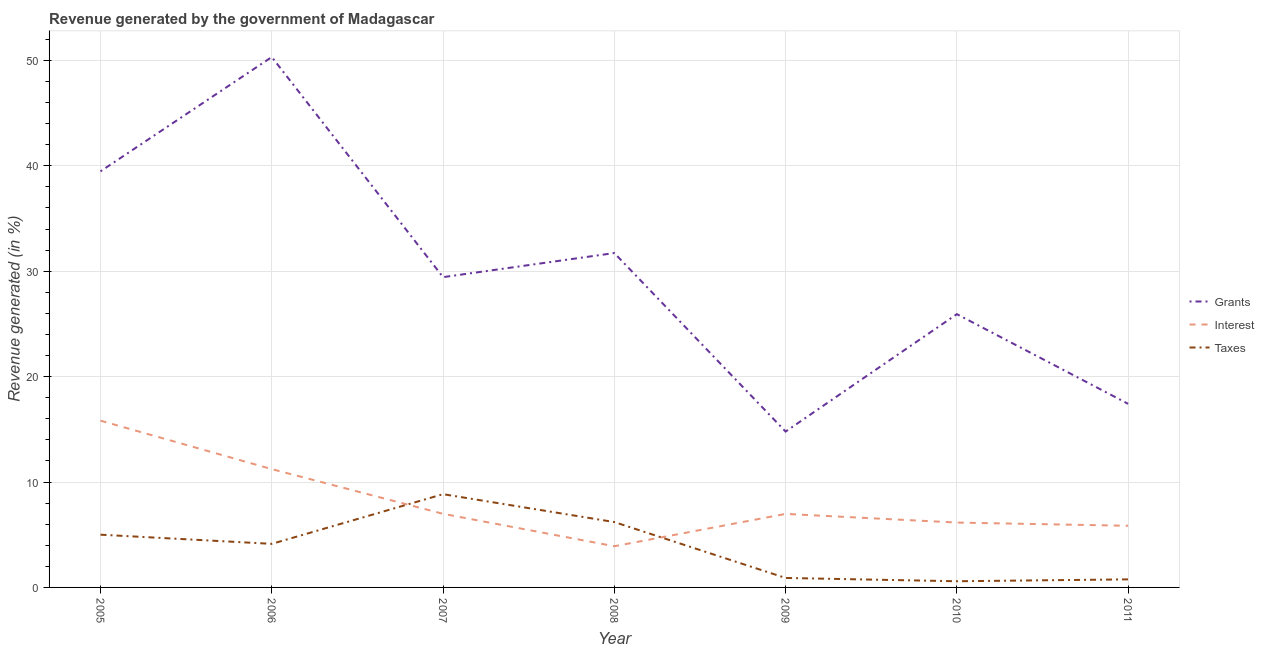How many different coloured lines are there?
Give a very brief answer. 3. What is the percentage of revenue generated by taxes in 2008?
Provide a succinct answer. 6.2. Across all years, what is the maximum percentage of revenue generated by taxes?
Make the answer very short. 8.85. Across all years, what is the minimum percentage of revenue generated by grants?
Your answer should be very brief. 14.79. What is the total percentage of revenue generated by interest in the graph?
Offer a very short reply. 56.91. What is the difference between the percentage of revenue generated by interest in 2005 and that in 2006?
Offer a very short reply. 4.6. What is the difference between the percentage of revenue generated by interest in 2008 and the percentage of revenue generated by grants in 2009?
Your answer should be very brief. -10.88. What is the average percentage of revenue generated by grants per year?
Provide a succinct answer. 29.87. In the year 2011, what is the difference between the percentage of revenue generated by grants and percentage of revenue generated by taxes?
Offer a very short reply. 16.65. In how many years, is the percentage of revenue generated by taxes greater than 34 %?
Your answer should be compact. 0. What is the ratio of the percentage of revenue generated by taxes in 2007 to that in 2011?
Give a very brief answer. 11.58. What is the difference between the highest and the second highest percentage of revenue generated by taxes?
Offer a terse response. 2.65. What is the difference between the highest and the lowest percentage of revenue generated by grants?
Your answer should be compact. 35.53. In how many years, is the percentage of revenue generated by taxes greater than the average percentage of revenue generated by taxes taken over all years?
Your answer should be very brief. 4. Is it the case that in every year, the sum of the percentage of revenue generated by grants and percentage of revenue generated by interest is greater than the percentage of revenue generated by taxes?
Provide a short and direct response. Yes. Does the percentage of revenue generated by taxes monotonically increase over the years?
Your answer should be very brief. No. Is the percentage of revenue generated by taxes strictly greater than the percentage of revenue generated by interest over the years?
Make the answer very short. No. What is the difference between two consecutive major ticks on the Y-axis?
Give a very brief answer. 10. Are the values on the major ticks of Y-axis written in scientific E-notation?
Provide a short and direct response. No. Does the graph contain grids?
Keep it short and to the point. Yes. How many legend labels are there?
Give a very brief answer. 3. How are the legend labels stacked?
Provide a short and direct response. Vertical. What is the title of the graph?
Keep it short and to the point. Revenue generated by the government of Madagascar. What is the label or title of the Y-axis?
Offer a very short reply. Revenue generated (in %). What is the Revenue generated (in %) in Grants in 2005?
Provide a succinct answer. 39.48. What is the Revenue generated (in %) in Interest in 2005?
Ensure brevity in your answer.  15.82. What is the Revenue generated (in %) of Taxes in 2005?
Make the answer very short. 5. What is the Revenue generated (in %) of Grants in 2006?
Give a very brief answer. 50.32. What is the Revenue generated (in %) of Interest in 2006?
Provide a short and direct response. 11.22. What is the Revenue generated (in %) in Taxes in 2006?
Your answer should be very brief. 4.13. What is the Revenue generated (in %) of Grants in 2007?
Offer a very short reply. 29.44. What is the Revenue generated (in %) in Interest in 2007?
Your answer should be very brief. 6.98. What is the Revenue generated (in %) of Taxes in 2007?
Your answer should be compact. 8.85. What is the Revenue generated (in %) of Grants in 2008?
Offer a very short reply. 31.72. What is the Revenue generated (in %) in Interest in 2008?
Offer a very short reply. 3.91. What is the Revenue generated (in %) of Taxes in 2008?
Your response must be concise. 6.2. What is the Revenue generated (in %) of Grants in 2009?
Offer a terse response. 14.79. What is the Revenue generated (in %) in Interest in 2009?
Provide a short and direct response. 6.98. What is the Revenue generated (in %) in Taxes in 2009?
Offer a very short reply. 0.9. What is the Revenue generated (in %) in Grants in 2010?
Your response must be concise. 25.93. What is the Revenue generated (in %) in Interest in 2010?
Your answer should be very brief. 6.15. What is the Revenue generated (in %) of Taxes in 2010?
Provide a short and direct response. 0.59. What is the Revenue generated (in %) of Grants in 2011?
Offer a very short reply. 17.42. What is the Revenue generated (in %) in Interest in 2011?
Your answer should be very brief. 5.85. What is the Revenue generated (in %) of Taxes in 2011?
Give a very brief answer. 0.76. Across all years, what is the maximum Revenue generated (in %) in Grants?
Offer a terse response. 50.32. Across all years, what is the maximum Revenue generated (in %) in Interest?
Keep it short and to the point. 15.82. Across all years, what is the maximum Revenue generated (in %) in Taxes?
Offer a very short reply. 8.85. Across all years, what is the minimum Revenue generated (in %) of Grants?
Keep it short and to the point. 14.79. Across all years, what is the minimum Revenue generated (in %) of Interest?
Provide a succinct answer. 3.91. Across all years, what is the minimum Revenue generated (in %) in Taxes?
Provide a succinct answer. 0.59. What is the total Revenue generated (in %) in Grants in the graph?
Offer a very short reply. 209.08. What is the total Revenue generated (in %) in Interest in the graph?
Provide a succinct answer. 56.91. What is the total Revenue generated (in %) in Taxes in the graph?
Your response must be concise. 26.43. What is the difference between the Revenue generated (in %) in Grants in 2005 and that in 2006?
Offer a terse response. -10.84. What is the difference between the Revenue generated (in %) in Interest in 2005 and that in 2006?
Provide a short and direct response. 4.6. What is the difference between the Revenue generated (in %) of Taxes in 2005 and that in 2006?
Your answer should be very brief. 0.87. What is the difference between the Revenue generated (in %) of Grants in 2005 and that in 2007?
Ensure brevity in your answer.  10.04. What is the difference between the Revenue generated (in %) in Interest in 2005 and that in 2007?
Your answer should be very brief. 8.84. What is the difference between the Revenue generated (in %) of Taxes in 2005 and that in 2007?
Your answer should be very brief. -3.84. What is the difference between the Revenue generated (in %) in Grants in 2005 and that in 2008?
Give a very brief answer. 7.75. What is the difference between the Revenue generated (in %) in Interest in 2005 and that in 2008?
Offer a terse response. 11.91. What is the difference between the Revenue generated (in %) in Taxes in 2005 and that in 2008?
Give a very brief answer. -1.2. What is the difference between the Revenue generated (in %) in Grants in 2005 and that in 2009?
Your response must be concise. 24.69. What is the difference between the Revenue generated (in %) in Interest in 2005 and that in 2009?
Give a very brief answer. 8.85. What is the difference between the Revenue generated (in %) in Taxes in 2005 and that in 2009?
Your answer should be compact. 4.1. What is the difference between the Revenue generated (in %) in Grants in 2005 and that in 2010?
Offer a very short reply. 13.55. What is the difference between the Revenue generated (in %) in Interest in 2005 and that in 2010?
Your answer should be compact. 9.67. What is the difference between the Revenue generated (in %) of Taxes in 2005 and that in 2010?
Offer a very short reply. 4.42. What is the difference between the Revenue generated (in %) of Grants in 2005 and that in 2011?
Your response must be concise. 22.06. What is the difference between the Revenue generated (in %) in Interest in 2005 and that in 2011?
Provide a short and direct response. 9.97. What is the difference between the Revenue generated (in %) in Taxes in 2005 and that in 2011?
Your response must be concise. 4.24. What is the difference between the Revenue generated (in %) in Grants in 2006 and that in 2007?
Provide a short and direct response. 20.88. What is the difference between the Revenue generated (in %) of Interest in 2006 and that in 2007?
Offer a very short reply. 4.24. What is the difference between the Revenue generated (in %) in Taxes in 2006 and that in 2007?
Provide a short and direct response. -4.71. What is the difference between the Revenue generated (in %) of Grants in 2006 and that in 2008?
Your answer should be very brief. 18.6. What is the difference between the Revenue generated (in %) of Interest in 2006 and that in 2008?
Your answer should be compact. 7.32. What is the difference between the Revenue generated (in %) in Taxes in 2006 and that in 2008?
Offer a very short reply. -2.07. What is the difference between the Revenue generated (in %) in Grants in 2006 and that in 2009?
Provide a short and direct response. 35.53. What is the difference between the Revenue generated (in %) in Interest in 2006 and that in 2009?
Offer a terse response. 4.25. What is the difference between the Revenue generated (in %) of Taxes in 2006 and that in 2009?
Give a very brief answer. 3.23. What is the difference between the Revenue generated (in %) of Grants in 2006 and that in 2010?
Provide a short and direct response. 24.39. What is the difference between the Revenue generated (in %) of Interest in 2006 and that in 2010?
Your answer should be compact. 5.07. What is the difference between the Revenue generated (in %) in Taxes in 2006 and that in 2010?
Provide a succinct answer. 3.55. What is the difference between the Revenue generated (in %) in Grants in 2006 and that in 2011?
Your answer should be compact. 32.9. What is the difference between the Revenue generated (in %) of Interest in 2006 and that in 2011?
Give a very brief answer. 5.37. What is the difference between the Revenue generated (in %) in Taxes in 2006 and that in 2011?
Ensure brevity in your answer.  3.37. What is the difference between the Revenue generated (in %) of Grants in 2007 and that in 2008?
Your response must be concise. -2.29. What is the difference between the Revenue generated (in %) in Interest in 2007 and that in 2008?
Your response must be concise. 3.07. What is the difference between the Revenue generated (in %) in Taxes in 2007 and that in 2008?
Your answer should be compact. 2.65. What is the difference between the Revenue generated (in %) of Grants in 2007 and that in 2009?
Provide a succinct answer. 14.65. What is the difference between the Revenue generated (in %) of Interest in 2007 and that in 2009?
Your answer should be compact. 0.01. What is the difference between the Revenue generated (in %) in Taxes in 2007 and that in 2009?
Offer a very short reply. 7.95. What is the difference between the Revenue generated (in %) in Grants in 2007 and that in 2010?
Your answer should be very brief. 3.51. What is the difference between the Revenue generated (in %) of Interest in 2007 and that in 2010?
Ensure brevity in your answer.  0.83. What is the difference between the Revenue generated (in %) of Taxes in 2007 and that in 2010?
Your response must be concise. 8.26. What is the difference between the Revenue generated (in %) in Grants in 2007 and that in 2011?
Your answer should be compact. 12.02. What is the difference between the Revenue generated (in %) in Interest in 2007 and that in 2011?
Offer a very short reply. 1.13. What is the difference between the Revenue generated (in %) of Taxes in 2007 and that in 2011?
Offer a terse response. 8.08. What is the difference between the Revenue generated (in %) of Grants in 2008 and that in 2009?
Offer a terse response. 16.93. What is the difference between the Revenue generated (in %) of Interest in 2008 and that in 2009?
Your response must be concise. -3.07. What is the difference between the Revenue generated (in %) of Taxes in 2008 and that in 2009?
Provide a short and direct response. 5.3. What is the difference between the Revenue generated (in %) in Grants in 2008 and that in 2010?
Give a very brief answer. 5.8. What is the difference between the Revenue generated (in %) of Interest in 2008 and that in 2010?
Provide a succinct answer. -2.25. What is the difference between the Revenue generated (in %) of Taxes in 2008 and that in 2010?
Your answer should be compact. 5.61. What is the difference between the Revenue generated (in %) in Grants in 2008 and that in 2011?
Offer a terse response. 14.3. What is the difference between the Revenue generated (in %) of Interest in 2008 and that in 2011?
Make the answer very short. -1.94. What is the difference between the Revenue generated (in %) in Taxes in 2008 and that in 2011?
Make the answer very short. 5.44. What is the difference between the Revenue generated (in %) of Grants in 2009 and that in 2010?
Your response must be concise. -11.14. What is the difference between the Revenue generated (in %) in Interest in 2009 and that in 2010?
Provide a short and direct response. 0.82. What is the difference between the Revenue generated (in %) of Taxes in 2009 and that in 2010?
Your answer should be compact. 0.31. What is the difference between the Revenue generated (in %) in Grants in 2009 and that in 2011?
Your answer should be very brief. -2.63. What is the difference between the Revenue generated (in %) in Interest in 2009 and that in 2011?
Provide a succinct answer. 1.13. What is the difference between the Revenue generated (in %) in Taxes in 2009 and that in 2011?
Offer a terse response. 0.14. What is the difference between the Revenue generated (in %) of Grants in 2010 and that in 2011?
Keep it short and to the point. 8.51. What is the difference between the Revenue generated (in %) in Interest in 2010 and that in 2011?
Your response must be concise. 0.3. What is the difference between the Revenue generated (in %) of Taxes in 2010 and that in 2011?
Your response must be concise. -0.18. What is the difference between the Revenue generated (in %) in Grants in 2005 and the Revenue generated (in %) in Interest in 2006?
Give a very brief answer. 28.25. What is the difference between the Revenue generated (in %) in Grants in 2005 and the Revenue generated (in %) in Taxes in 2006?
Ensure brevity in your answer.  35.34. What is the difference between the Revenue generated (in %) in Interest in 2005 and the Revenue generated (in %) in Taxes in 2006?
Provide a succinct answer. 11.69. What is the difference between the Revenue generated (in %) of Grants in 2005 and the Revenue generated (in %) of Interest in 2007?
Keep it short and to the point. 32.49. What is the difference between the Revenue generated (in %) in Grants in 2005 and the Revenue generated (in %) in Taxes in 2007?
Give a very brief answer. 30.63. What is the difference between the Revenue generated (in %) in Interest in 2005 and the Revenue generated (in %) in Taxes in 2007?
Your response must be concise. 6.97. What is the difference between the Revenue generated (in %) of Grants in 2005 and the Revenue generated (in %) of Interest in 2008?
Give a very brief answer. 35.57. What is the difference between the Revenue generated (in %) in Grants in 2005 and the Revenue generated (in %) in Taxes in 2008?
Make the answer very short. 33.27. What is the difference between the Revenue generated (in %) of Interest in 2005 and the Revenue generated (in %) of Taxes in 2008?
Ensure brevity in your answer.  9.62. What is the difference between the Revenue generated (in %) of Grants in 2005 and the Revenue generated (in %) of Interest in 2009?
Provide a succinct answer. 32.5. What is the difference between the Revenue generated (in %) in Grants in 2005 and the Revenue generated (in %) in Taxes in 2009?
Ensure brevity in your answer.  38.58. What is the difference between the Revenue generated (in %) in Interest in 2005 and the Revenue generated (in %) in Taxes in 2009?
Your response must be concise. 14.92. What is the difference between the Revenue generated (in %) in Grants in 2005 and the Revenue generated (in %) in Interest in 2010?
Keep it short and to the point. 33.32. What is the difference between the Revenue generated (in %) of Grants in 2005 and the Revenue generated (in %) of Taxes in 2010?
Your answer should be very brief. 38.89. What is the difference between the Revenue generated (in %) of Interest in 2005 and the Revenue generated (in %) of Taxes in 2010?
Your answer should be compact. 15.23. What is the difference between the Revenue generated (in %) of Grants in 2005 and the Revenue generated (in %) of Interest in 2011?
Keep it short and to the point. 33.63. What is the difference between the Revenue generated (in %) of Grants in 2005 and the Revenue generated (in %) of Taxes in 2011?
Your answer should be compact. 38.71. What is the difference between the Revenue generated (in %) in Interest in 2005 and the Revenue generated (in %) in Taxes in 2011?
Your answer should be compact. 15.06. What is the difference between the Revenue generated (in %) of Grants in 2006 and the Revenue generated (in %) of Interest in 2007?
Give a very brief answer. 43.33. What is the difference between the Revenue generated (in %) in Grants in 2006 and the Revenue generated (in %) in Taxes in 2007?
Your response must be concise. 41.47. What is the difference between the Revenue generated (in %) in Interest in 2006 and the Revenue generated (in %) in Taxes in 2007?
Provide a succinct answer. 2.38. What is the difference between the Revenue generated (in %) in Grants in 2006 and the Revenue generated (in %) in Interest in 2008?
Give a very brief answer. 46.41. What is the difference between the Revenue generated (in %) of Grants in 2006 and the Revenue generated (in %) of Taxes in 2008?
Ensure brevity in your answer.  44.12. What is the difference between the Revenue generated (in %) in Interest in 2006 and the Revenue generated (in %) in Taxes in 2008?
Provide a short and direct response. 5.02. What is the difference between the Revenue generated (in %) of Grants in 2006 and the Revenue generated (in %) of Interest in 2009?
Provide a succinct answer. 43.34. What is the difference between the Revenue generated (in %) of Grants in 2006 and the Revenue generated (in %) of Taxes in 2009?
Offer a very short reply. 49.42. What is the difference between the Revenue generated (in %) in Interest in 2006 and the Revenue generated (in %) in Taxes in 2009?
Your answer should be very brief. 10.32. What is the difference between the Revenue generated (in %) of Grants in 2006 and the Revenue generated (in %) of Interest in 2010?
Your answer should be compact. 44.16. What is the difference between the Revenue generated (in %) of Grants in 2006 and the Revenue generated (in %) of Taxes in 2010?
Your answer should be very brief. 49.73. What is the difference between the Revenue generated (in %) in Interest in 2006 and the Revenue generated (in %) in Taxes in 2010?
Provide a succinct answer. 10.64. What is the difference between the Revenue generated (in %) in Grants in 2006 and the Revenue generated (in %) in Interest in 2011?
Provide a short and direct response. 44.47. What is the difference between the Revenue generated (in %) in Grants in 2006 and the Revenue generated (in %) in Taxes in 2011?
Keep it short and to the point. 49.55. What is the difference between the Revenue generated (in %) of Interest in 2006 and the Revenue generated (in %) of Taxes in 2011?
Your answer should be very brief. 10.46. What is the difference between the Revenue generated (in %) in Grants in 2007 and the Revenue generated (in %) in Interest in 2008?
Ensure brevity in your answer.  25.53. What is the difference between the Revenue generated (in %) in Grants in 2007 and the Revenue generated (in %) in Taxes in 2008?
Keep it short and to the point. 23.24. What is the difference between the Revenue generated (in %) in Interest in 2007 and the Revenue generated (in %) in Taxes in 2008?
Provide a short and direct response. 0.78. What is the difference between the Revenue generated (in %) of Grants in 2007 and the Revenue generated (in %) of Interest in 2009?
Your response must be concise. 22.46. What is the difference between the Revenue generated (in %) of Grants in 2007 and the Revenue generated (in %) of Taxes in 2009?
Your response must be concise. 28.54. What is the difference between the Revenue generated (in %) in Interest in 2007 and the Revenue generated (in %) in Taxes in 2009?
Keep it short and to the point. 6.08. What is the difference between the Revenue generated (in %) of Grants in 2007 and the Revenue generated (in %) of Interest in 2010?
Your response must be concise. 23.28. What is the difference between the Revenue generated (in %) of Grants in 2007 and the Revenue generated (in %) of Taxes in 2010?
Keep it short and to the point. 28.85. What is the difference between the Revenue generated (in %) in Interest in 2007 and the Revenue generated (in %) in Taxes in 2010?
Offer a very short reply. 6.4. What is the difference between the Revenue generated (in %) of Grants in 2007 and the Revenue generated (in %) of Interest in 2011?
Your answer should be compact. 23.59. What is the difference between the Revenue generated (in %) of Grants in 2007 and the Revenue generated (in %) of Taxes in 2011?
Offer a terse response. 28.67. What is the difference between the Revenue generated (in %) in Interest in 2007 and the Revenue generated (in %) in Taxes in 2011?
Offer a terse response. 6.22. What is the difference between the Revenue generated (in %) in Grants in 2008 and the Revenue generated (in %) in Interest in 2009?
Your answer should be very brief. 24.75. What is the difference between the Revenue generated (in %) in Grants in 2008 and the Revenue generated (in %) in Taxes in 2009?
Keep it short and to the point. 30.82. What is the difference between the Revenue generated (in %) in Interest in 2008 and the Revenue generated (in %) in Taxes in 2009?
Your answer should be compact. 3.01. What is the difference between the Revenue generated (in %) in Grants in 2008 and the Revenue generated (in %) in Interest in 2010?
Give a very brief answer. 25.57. What is the difference between the Revenue generated (in %) of Grants in 2008 and the Revenue generated (in %) of Taxes in 2010?
Ensure brevity in your answer.  31.14. What is the difference between the Revenue generated (in %) in Interest in 2008 and the Revenue generated (in %) in Taxes in 2010?
Your answer should be very brief. 3.32. What is the difference between the Revenue generated (in %) of Grants in 2008 and the Revenue generated (in %) of Interest in 2011?
Keep it short and to the point. 25.87. What is the difference between the Revenue generated (in %) in Grants in 2008 and the Revenue generated (in %) in Taxes in 2011?
Ensure brevity in your answer.  30.96. What is the difference between the Revenue generated (in %) of Interest in 2008 and the Revenue generated (in %) of Taxes in 2011?
Keep it short and to the point. 3.14. What is the difference between the Revenue generated (in %) in Grants in 2009 and the Revenue generated (in %) in Interest in 2010?
Keep it short and to the point. 8.63. What is the difference between the Revenue generated (in %) in Grants in 2009 and the Revenue generated (in %) in Taxes in 2010?
Give a very brief answer. 14.2. What is the difference between the Revenue generated (in %) in Interest in 2009 and the Revenue generated (in %) in Taxes in 2010?
Your response must be concise. 6.39. What is the difference between the Revenue generated (in %) in Grants in 2009 and the Revenue generated (in %) in Interest in 2011?
Keep it short and to the point. 8.94. What is the difference between the Revenue generated (in %) of Grants in 2009 and the Revenue generated (in %) of Taxes in 2011?
Your answer should be compact. 14.02. What is the difference between the Revenue generated (in %) of Interest in 2009 and the Revenue generated (in %) of Taxes in 2011?
Provide a succinct answer. 6.21. What is the difference between the Revenue generated (in %) of Grants in 2010 and the Revenue generated (in %) of Interest in 2011?
Provide a succinct answer. 20.08. What is the difference between the Revenue generated (in %) of Grants in 2010 and the Revenue generated (in %) of Taxes in 2011?
Keep it short and to the point. 25.16. What is the difference between the Revenue generated (in %) in Interest in 2010 and the Revenue generated (in %) in Taxes in 2011?
Offer a very short reply. 5.39. What is the average Revenue generated (in %) of Grants per year?
Your response must be concise. 29.87. What is the average Revenue generated (in %) of Interest per year?
Your answer should be compact. 8.13. What is the average Revenue generated (in %) in Taxes per year?
Offer a terse response. 3.78. In the year 2005, what is the difference between the Revenue generated (in %) in Grants and Revenue generated (in %) in Interest?
Your answer should be very brief. 23.65. In the year 2005, what is the difference between the Revenue generated (in %) in Grants and Revenue generated (in %) in Taxes?
Provide a short and direct response. 34.47. In the year 2005, what is the difference between the Revenue generated (in %) in Interest and Revenue generated (in %) in Taxes?
Your answer should be very brief. 10.82. In the year 2006, what is the difference between the Revenue generated (in %) of Grants and Revenue generated (in %) of Interest?
Your answer should be compact. 39.09. In the year 2006, what is the difference between the Revenue generated (in %) of Grants and Revenue generated (in %) of Taxes?
Keep it short and to the point. 46.18. In the year 2006, what is the difference between the Revenue generated (in %) in Interest and Revenue generated (in %) in Taxes?
Provide a succinct answer. 7.09. In the year 2007, what is the difference between the Revenue generated (in %) in Grants and Revenue generated (in %) in Interest?
Your answer should be compact. 22.45. In the year 2007, what is the difference between the Revenue generated (in %) of Grants and Revenue generated (in %) of Taxes?
Your answer should be very brief. 20.59. In the year 2007, what is the difference between the Revenue generated (in %) of Interest and Revenue generated (in %) of Taxes?
Your answer should be very brief. -1.86. In the year 2008, what is the difference between the Revenue generated (in %) of Grants and Revenue generated (in %) of Interest?
Give a very brief answer. 27.81. In the year 2008, what is the difference between the Revenue generated (in %) in Grants and Revenue generated (in %) in Taxes?
Your response must be concise. 25.52. In the year 2008, what is the difference between the Revenue generated (in %) in Interest and Revenue generated (in %) in Taxes?
Your response must be concise. -2.29. In the year 2009, what is the difference between the Revenue generated (in %) of Grants and Revenue generated (in %) of Interest?
Provide a succinct answer. 7.81. In the year 2009, what is the difference between the Revenue generated (in %) in Grants and Revenue generated (in %) in Taxes?
Keep it short and to the point. 13.89. In the year 2009, what is the difference between the Revenue generated (in %) in Interest and Revenue generated (in %) in Taxes?
Your response must be concise. 6.08. In the year 2010, what is the difference between the Revenue generated (in %) in Grants and Revenue generated (in %) in Interest?
Your answer should be compact. 19.77. In the year 2010, what is the difference between the Revenue generated (in %) in Grants and Revenue generated (in %) in Taxes?
Ensure brevity in your answer.  25.34. In the year 2010, what is the difference between the Revenue generated (in %) of Interest and Revenue generated (in %) of Taxes?
Ensure brevity in your answer.  5.57. In the year 2011, what is the difference between the Revenue generated (in %) of Grants and Revenue generated (in %) of Interest?
Provide a succinct answer. 11.57. In the year 2011, what is the difference between the Revenue generated (in %) in Grants and Revenue generated (in %) in Taxes?
Offer a terse response. 16.65. In the year 2011, what is the difference between the Revenue generated (in %) of Interest and Revenue generated (in %) of Taxes?
Your response must be concise. 5.08. What is the ratio of the Revenue generated (in %) in Grants in 2005 to that in 2006?
Keep it short and to the point. 0.78. What is the ratio of the Revenue generated (in %) in Interest in 2005 to that in 2006?
Keep it short and to the point. 1.41. What is the ratio of the Revenue generated (in %) of Taxes in 2005 to that in 2006?
Your response must be concise. 1.21. What is the ratio of the Revenue generated (in %) in Grants in 2005 to that in 2007?
Your answer should be compact. 1.34. What is the ratio of the Revenue generated (in %) of Interest in 2005 to that in 2007?
Your response must be concise. 2.27. What is the ratio of the Revenue generated (in %) of Taxes in 2005 to that in 2007?
Provide a short and direct response. 0.57. What is the ratio of the Revenue generated (in %) in Grants in 2005 to that in 2008?
Keep it short and to the point. 1.24. What is the ratio of the Revenue generated (in %) in Interest in 2005 to that in 2008?
Offer a very short reply. 4.05. What is the ratio of the Revenue generated (in %) in Taxes in 2005 to that in 2008?
Your response must be concise. 0.81. What is the ratio of the Revenue generated (in %) of Grants in 2005 to that in 2009?
Keep it short and to the point. 2.67. What is the ratio of the Revenue generated (in %) in Interest in 2005 to that in 2009?
Your answer should be very brief. 2.27. What is the ratio of the Revenue generated (in %) of Taxes in 2005 to that in 2009?
Ensure brevity in your answer.  5.57. What is the ratio of the Revenue generated (in %) of Grants in 2005 to that in 2010?
Keep it short and to the point. 1.52. What is the ratio of the Revenue generated (in %) of Interest in 2005 to that in 2010?
Provide a succinct answer. 2.57. What is the ratio of the Revenue generated (in %) in Taxes in 2005 to that in 2010?
Keep it short and to the point. 8.53. What is the ratio of the Revenue generated (in %) in Grants in 2005 to that in 2011?
Offer a very short reply. 2.27. What is the ratio of the Revenue generated (in %) in Interest in 2005 to that in 2011?
Ensure brevity in your answer.  2.71. What is the ratio of the Revenue generated (in %) of Taxes in 2005 to that in 2011?
Provide a short and direct response. 6.55. What is the ratio of the Revenue generated (in %) in Grants in 2006 to that in 2007?
Give a very brief answer. 1.71. What is the ratio of the Revenue generated (in %) of Interest in 2006 to that in 2007?
Offer a terse response. 1.61. What is the ratio of the Revenue generated (in %) of Taxes in 2006 to that in 2007?
Ensure brevity in your answer.  0.47. What is the ratio of the Revenue generated (in %) in Grants in 2006 to that in 2008?
Ensure brevity in your answer.  1.59. What is the ratio of the Revenue generated (in %) of Interest in 2006 to that in 2008?
Your response must be concise. 2.87. What is the ratio of the Revenue generated (in %) in Taxes in 2006 to that in 2008?
Your answer should be compact. 0.67. What is the ratio of the Revenue generated (in %) of Grants in 2006 to that in 2009?
Keep it short and to the point. 3.4. What is the ratio of the Revenue generated (in %) of Interest in 2006 to that in 2009?
Your response must be concise. 1.61. What is the ratio of the Revenue generated (in %) in Taxes in 2006 to that in 2009?
Make the answer very short. 4.6. What is the ratio of the Revenue generated (in %) of Grants in 2006 to that in 2010?
Offer a very short reply. 1.94. What is the ratio of the Revenue generated (in %) of Interest in 2006 to that in 2010?
Ensure brevity in your answer.  1.82. What is the ratio of the Revenue generated (in %) of Taxes in 2006 to that in 2010?
Keep it short and to the point. 7.05. What is the ratio of the Revenue generated (in %) of Grants in 2006 to that in 2011?
Ensure brevity in your answer.  2.89. What is the ratio of the Revenue generated (in %) in Interest in 2006 to that in 2011?
Keep it short and to the point. 1.92. What is the ratio of the Revenue generated (in %) in Taxes in 2006 to that in 2011?
Keep it short and to the point. 5.41. What is the ratio of the Revenue generated (in %) in Grants in 2007 to that in 2008?
Provide a succinct answer. 0.93. What is the ratio of the Revenue generated (in %) in Interest in 2007 to that in 2008?
Provide a succinct answer. 1.79. What is the ratio of the Revenue generated (in %) of Taxes in 2007 to that in 2008?
Your answer should be compact. 1.43. What is the ratio of the Revenue generated (in %) of Grants in 2007 to that in 2009?
Your answer should be compact. 1.99. What is the ratio of the Revenue generated (in %) of Taxes in 2007 to that in 2009?
Make the answer very short. 9.84. What is the ratio of the Revenue generated (in %) of Grants in 2007 to that in 2010?
Ensure brevity in your answer.  1.14. What is the ratio of the Revenue generated (in %) in Interest in 2007 to that in 2010?
Your answer should be compact. 1.13. What is the ratio of the Revenue generated (in %) of Taxes in 2007 to that in 2010?
Ensure brevity in your answer.  15.09. What is the ratio of the Revenue generated (in %) of Grants in 2007 to that in 2011?
Your answer should be very brief. 1.69. What is the ratio of the Revenue generated (in %) in Interest in 2007 to that in 2011?
Your answer should be very brief. 1.19. What is the ratio of the Revenue generated (in %) in Taxes in 2007 to that in 2011?
Your answer should be compact. 11.58. What is the ratio of the Revenue generated (in %) of Grants in 2008 to that in 2009?
Your answer should be very brief. 2.15. What is the ratio of the Revenue generated (in %) of Interest in 2008 to that in 2009?
Make the answer very short. 0.56. What is the ratio of the Revenue generated (in %) in Taxes in 2008 to that in 2009?
Ensure brevity in your answer.  6.9. What is the ratio of the Revenue generated (in %) in Grants in 2008 to that in 2010?
Offer a very short reply. 1.22. What is the ratio of the Revenue generated (in %) in Interest in 2008 to that in 2010?
Your answer should be very brief. 0.64. What is the ratio of the Revenue generated (in %) in Taxes in 2008 to that in 2010?
Provide a short and direct response. 10.58. What is the ratio of the Revenue generated (in %) in Grants in 2008 to that in 2011?
Make the answer very short. 1.82. What is the ratio of the Revenue generated (in %) of Interest in 2008 to that in 2011?
Your answer should be very brief. 0.67. What is the ratio of the Revenue generated (in %) of Taxes in 2008 to that in 2011?
Provide a succinct answer. 8.12. What is the ratio of the Revenue generated (in %) in Grants in 2009 to that in 2010?
Provide a succinct answer. 0.57. What is the ratio of the Revenue generated (in %) in Interest in 2009 to that in 2010?
Make the answer very short. 1.13. What is the ratio of the Revenue generated (in %) in Taxes in 2009 to that in 2010?
Your response must be concise. 1.53. What is the ratio of the Revenue generated (in %) of Grants in 2009 to that in 2011?
Offer a terse response. 0.85. What is the ratio of the Revenue generated (in %) in Interest in 2009 to that in 2011?
Provide a short and direct response. 1.19. What is the ratio of the Revenue generated (in %) in Taxes in 2009 to that in 2011?
Provide a succinct answer. 1.18. What is the ratio of the Revenue generated (in %) of Grants in 2010 to that in 2011?
Make the answer very short. 1.49. What is the ratio of the Revenue generated (in %) of Interest in 2010 to that in 2011?
Keep it short and to the point. 1.05. What is the ratio of the Revenue generated (in %) in Taxes in 2010 to that in 2011?
Ensure brevity in your answer.  0.77. What is the difference between the highest and the second highest Revenue generated (in %) of Grants?
Provide a short and direct response. 10.84. What is the difference between the highest and the second highest Revenue generated (in %) of Interest?
Offer a very short reply. 4.6. What is the difference between the highest and the second highest Revenue generated (in %) of Taxes?
Offer a terse response. 2.65. What is the difference between the highest and the lowest Revenue generated (in %) in Grants?
Your answer should be very brief. 35.53. What is the difference between the highest and the lowest Revenue generated (in %) in Interest?
Keep it short and to the point. 11.91. What is the difference between the highest and the lowest Revenue generated (in %) of Taxes?
Keep it short and to the point. 8.26. 